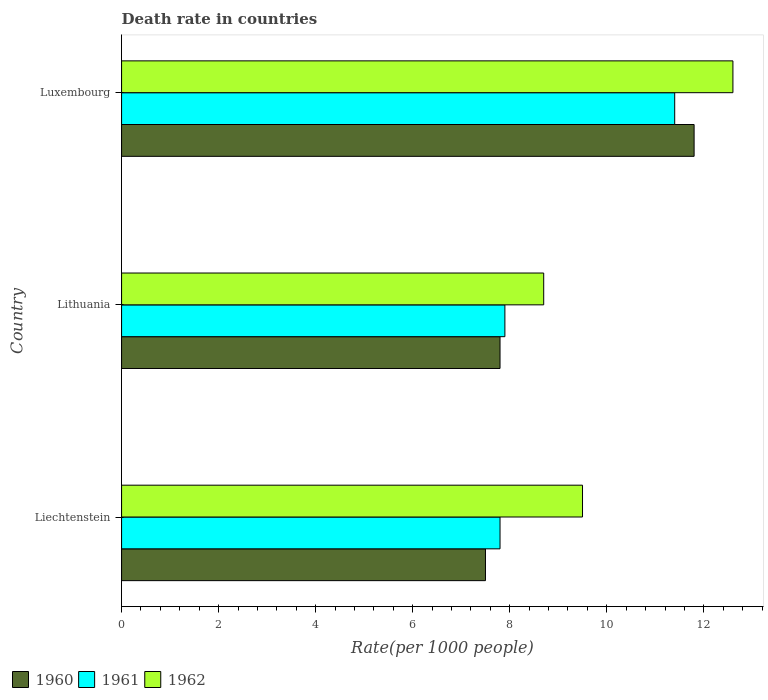What is the label of the 2nd group of bars from the top?
Keep it short and to the point. Lithuania. What is the death rate in 1961 in Luxembourg?
Make the answer very short. 11.4. In which country was the death rate in 1960 maximum?
Your answer should be compact. Luxembourg. In which country was the death rate in 1960 minimum?
Offer a very short reply. Liechtenstein. What is the total death rate in 1961 in the graph?
Your answer should be very brief. 27.1. What is the difference between the death rate in 1962 in Liechtenstein and that in Luxembourg?
Offer a terse response. -3.1. What is the difference between the death rate in 1962 in Luxembourg and the death rate in 1961 in Liechtenstein?
Provide a short and direct response. 4.8. What is the average death rate in 1960 per country?
Provide a succinct answer. 9.03. What is the difference between the death rate in 1962 and death rate in 1960 in Luxembourg?
Your response must be concise. 0.8. What is the ratio of the death rate in 1961 in Lithuania to that in Luxembourg?
Your answer should be very brief. 0.69. Is the death rate in 1961 in Liechtenstein less than that in Lithuania?
Provide a short and direct response. Yes. What is the difference between the highest and the second highest death rate in 1960?
Provide a short and direct response. 4. What is the difference between the highest and the lowest death rate in 1962?
Make the answer very short. 3.9. In how many countries, is the death rate in 1962 greater than the average death rate in 1962 taken over all countries?
Your response must be concise. 1. How many bars are there?
Keep it short and to the point. 9. Are all the bars in the graph horizontal?
Your answer should be compact. Yes. Does the graph contain grids?
Your answer should be compact. No. How many legend labels are there?
Make the answer very short. 3. What is the title of the graph?
Offer a terse response. Death rate in countries. What is the label or title of the X-axis?
Offer a terse response. Rate(per 1000 people). What is the label or title of the Y-axis?
Ensure brevity in your answer.  Country. What is the Rate(per 1000 people) in 1960 in Liechtenstein?
Your answer should be compact. 7.5. What is the Rate(per 1000 people) of 1960 in Luxembourg?
Offer a terse response. 11.8. What is the Rate(per 1000 people) of 1961 in Luxembourg?
Keep it short and to the point. 11.4. Across all countries, what is the maximum Rate(per 1000 people) in 1962?
Give a very brief answer. 12.6. Across all countries, what is the minimum Rate(per 1000 people) in 1962?
Provide a succinct answer. 8.7. What is the total Rate(per 1000 people) of 1960 in the graph?
Keep it short and to the point. 27.1. What is the total Rate(per 1000 people) in 1961 in the graph?
Make the answer very short. 27.1. What is the total Rate(per 1000 people) in 1962 in the graph?
Provide a short and direct response. 30.8. What is the difference between the Rate(per 1000 people) in 1962 in Liechtenstein and that in Lithuania?
Your response must be concise. 0.8. What is the difference between the Rate(per 1000 people) in 1962 in Liechtenstein and that in Luxembourg?
Keep it short and to the point. -3.1. What is the difference between the Rate(per 1000 people) of 1962 in Lithuania and that in Luxembourg?
Provide a succinct answer. -3.9. What is the difference between the Rate(per 1000 people) in 1960 in Liechtenstein and the Rate(per 1000 people) in 1961 in Luxembourg?
Provide a short and direct response. -3.9. What is the difference between the Rate(per 1000 people) of 1960 in Liechtenstein and the Rate(per 1000 people) of 1962 in Luxembourg?
Keep it short and to the point. -5.1. What is the difference between the Rate(per 1000 people) of 1960 in Lithuania and the Rate(per 1000 people) of 1961 in Luxembourg?
Make the answer very short. -3.6. What is the difference between the Rate(per 1000 people) in 1960 in Lithuania and the Rate(per 1000 people) in 1962 in Luxembourg?
Provide a succinct answer. -4.8. What is the average Rate(per 1000 people) of 1960 per country?
Make the answer very short. 9.03. What is the average Rate(per 1000 people) of 1961 per country?
Your answer should be compact. 9.03. What is the average Rate(per 1000 people) in 1962 per country?
Keep it short and to the point. 10.27. What is the difference between the Rate(per 1000 people) in 1960 and Rate(per 1000 people) in 1961 in Lithuania?
Give a very brief answer. -0.1. What is the difference between the Rate(per 1000 people) in 1960 and Rate(per 1000 people) in 1962 in Lithuania?
Give a very brief answer. -0.9. What is the difference between the Rate(per 1000 people) of 1961 and Rate(per 1000 people) of 1962 in Lithuania?
Provide a succinct answer. -0.8. What is the difference between the Rate(per 1000 people) in 1960 and Rate(per 1000 people) in 1961 in Luxembourg?
Give a very brief answer. 0.4. What is the difference between the Rate(per 1000 people) of 1961 and Rate(per 1000 people) of 1962 in Luxembourg?
Offer a very short reply. -1.2. What is the ratio of the Rate(per 1000 people) of 1960 in Liechtenstein to that in Lithuania?
Provide a short and direct response. 0.96. What is the ratio of the Rate(per 1000 people) in 1961 in Liechtenstein to that in Lithuania?
Offer a terse response. 0.99. What is the ratio of the Rate(per 1000 people) in 1962 in Liechtenstein to that in Lithuania?
Give a very brief answer. 1.09. What is the ratio of the Rate(per 1000 people) of 1960 in Liechtenstein to that in Luxembourg?
Provide a succinct answer. 0.64. What is the ratio of the Rate(per 1000 people) in 1961 in Liechtenstein to that in Luxembourg?
Offer a very short reply. 0.68. What is the ratio of the Rate(per 1000 people) of 1962 in Liechtenstein to that in Luxembourg?
Provide a succinct answer. 0.75. What is the ratio of the Rate(per 1000 people) of 1960 in Lithuania to that in Luxembourg?
Provide a succinct answer. 0.66. What is the ratio of the Rate(per 1000 people) in 1961 in Lithuania to that in Luxembourg?
Your answer should be very brief. 0.69. What is the ratio of the Rate(per 1000 people) of 1962 in Lithuania to that in Luxembourg?
Your answer should be very brief. 0.69. What is the difference between the highest and the second highest Rate(per 1000 people) in 1960?
Provide a succinct answer. 4. What is the difference between the highest and the second highest Rate(per 1000 people) in 1961?
Your answer should be very brief. 3.5. What is the difference between the highest and the second highest Rate(per 1000 people) of 1962?
Offer a terse response. 3.1. What is the difference between the highest and the lowest Rate(per 1000 people) in 1961?
Keep it short and to the point. 3.6. What is the difference between the highest and the lowest Rate(per 1000 people) of 1962?
Provide a succinct answer. 3.9. 